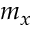<formula> <loc_0><loc_0><loc_500><loc_500>m _ { x }</formula> 